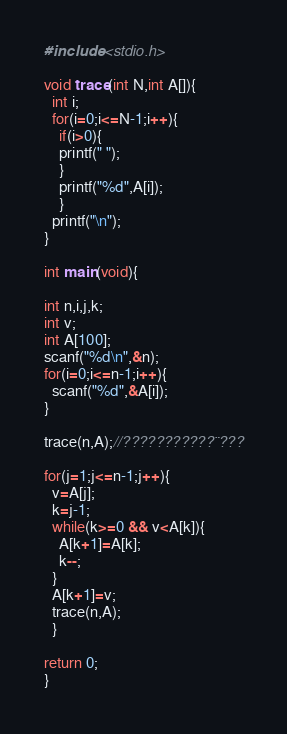Convert code to text. <code><loc_0><loc_0><loc_500><loc_500><_C_>#include <stdio.h>

void trace(int N,int A[]){
  int i;
  for(i=0;i<=N-1;i++){
    if(i>0){
    printf(" ");
    }
    printf("%d",A[i]);
    }
  printf("\n");
}

int main(void){

int n,i,j,k;
int v;
int A[100];
scanf("%d\n",&n);
for(i=0;i<=n-1;i++){
  scanf("%d",&A[i]);
}

trace(n,A);//???????????¨???

for(j=1;j<=n-1;j++){
  v=A[j];
  k=j-1;
  while(k>=0 && v<A[k]){
    A[k+1]=A[k];
    k--;
  }
  A[k+1]=v;
  trace(n,A);
  }

return 0;    
}</code> 